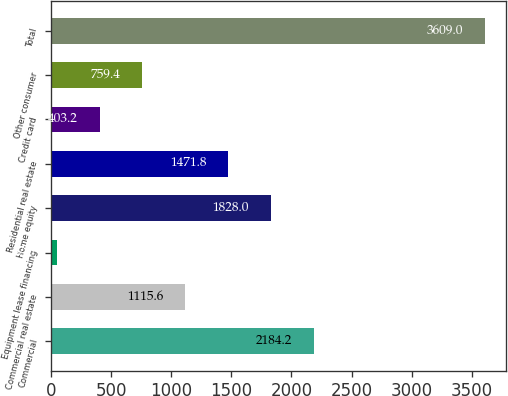<chart> <loc_0><loc_0><loc_500><loc_500><bar_chart><fcel>Commercial<fcel>Commercial real estate<fcel>Equipment lease financing<fcel>Home equity<fcel>Residential real estate<fcel>Credit card<fcel>Other consumer<fcel>Total<nl><fcel>2184.2<fcel>1115.6<fcel>47<fcel>1828<fcel>1471.8<fcel>403.2<fcel>759.4<fcel>3609<nl></chart> 